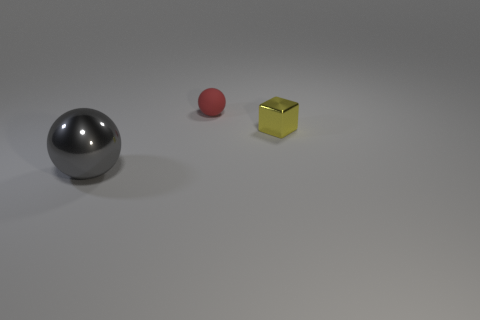Is there anything else that has the same material as the small red object?
Provide a succinct answer. No. Is there anything else that has the same size as the gray thing?
Give a very brief answer. No. There is a shiny sphere; is it the same size as the ball behind the gray object?
Make the answer very short. No. What is the shape of the tiny object that is to the right of the red object?
Offer a terse response. Cube. There is a ball that is to the left of the sphere that is behind the big object; what color is it?
Your answer should be very brief. Gray. The small matte object that is the same shape as the gray metal object is what color?
Your answer should be compact. Red. What number of small rubber objects have the same color as the big metallic sphere?
Provide a succinct answer. 0. There is a tiny metallic cube; is it the same color as the sphere behind the big gray sphere?
Make the answer very short. No. What is the shape of the object that is left of the small cube and in front of the red matte object?
Offer a very short reply. Sphere. What material is the ball behind the metal object that is in front of the small object in front of the tiny ball made of?
Your answer should be very brief. Rubber. 